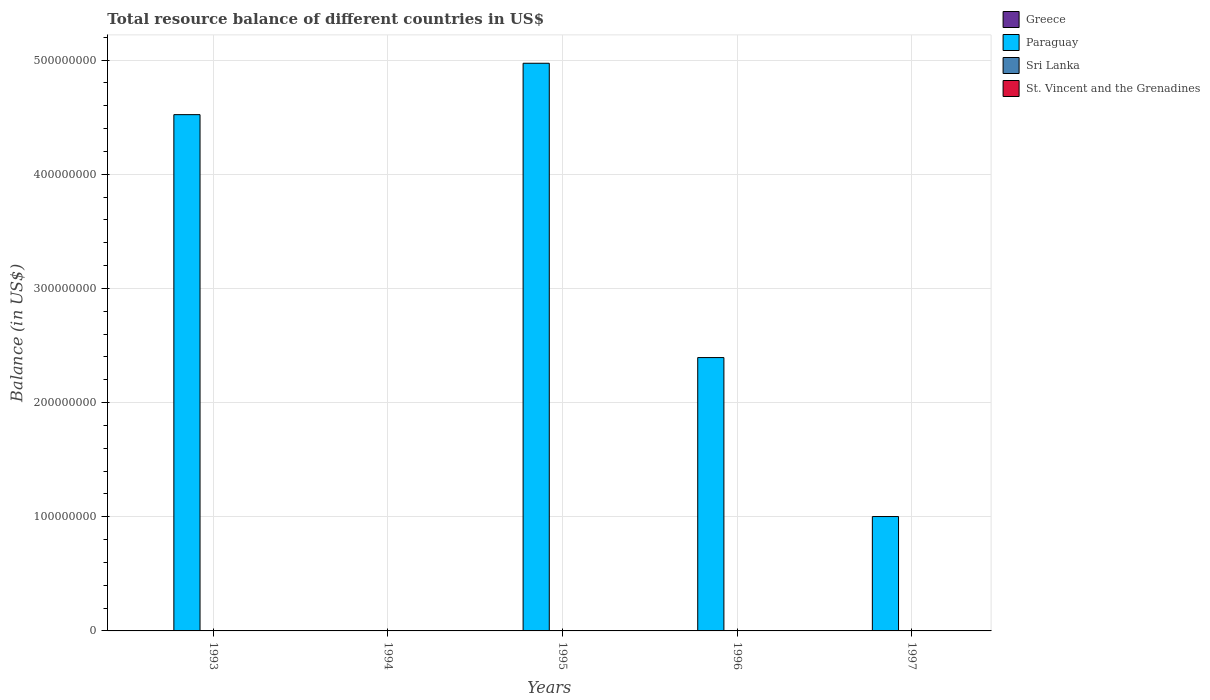Are the number of bars on each tick of the X-axis equal?
Your response must be concise. No. In how many cases, is the number of bars for a given year not equal to the number of legend labels?
Your answer should be very brief. 5. Across all years, what is the minimum total resource balance in Paraguay?
Your answer should be compact. 0. In which year was the total resource balance in Paraguay maximum?
Give a very brief answer. 1995. What is the total total resource balance in Paraguay in the graph?
Provide a short and direct response. 1.29e+09. What is the difference between the total resource balance in Paraguay in 1993 and that in 1997?
Give a very brief answer. 3.52e+08. What is the average total resource balance in Sri Lanka per year?
Your response must be concise. 0. In how many years, is the total resource balance in Greece greater than 180000000 US$?
Keep it short and to the point. 0. What is the ratio of the total resource balance in Paraguay in 1995 to that in 1996?
Your answer should be very brief. 2.08. What is the difference between the highest and the lowest total resource balance in Paraguay?
Ensure brevity in your answer.  4.97e+08. In how many years, is the total resource balance in St. Vincent and the Grenadines greater than the average total resource balance in St. Vincent and the Grenadines taken over all years?
Offer a terse response. 0. Is it the case that in every year, the sum of the total resource balance in St. Vincent and the Grenadines and total resource balance in Sri Lanka is greater than the sum of total resource balance in Paraguay and total resource balance in Greece?
Offer a very short reply. No. Is it the case that in every year, the sum of the total resource balance in Greece and total resource balance in St. Vincent and the Grenadines is greater than the total resource balance in Paraguay?
Make the answer very short. No. How many bars are there?
Provide a succinct answer. 4. How many years are there in the graph?
Keep it short and to the point. 5. Where does the legend appear in the graph?
Provide a short and direct response. Top right. What is the title of the graph?
Keep it short and to the point. Total resource balance of different countries in US$. What is the label or title of the Y-axis?
Your answer should be very brief. Balance (in US$). What is the Balance (in US$) of Greece in 1993?
Your response must be concise. 0. What is the Balance (in US$) in Paraguay in 1993?
Provide a short and direct response. 4.52e+08. What is the Balance (in US$) in Greece in 1994?
Offer a very short reply. 0. What is the Balance (in US$) of Paraguay in 1995?
Provide a succinct answer. 4.97e+08. What is the Balance (in US$) in Paraguay in 1996?
Make the answer very short. 2.39e+08. What is the Balance (in US$) of Sri Lanka in 1996?
Your answer should be compact. 0. What is the Balance (in US$) of Paraguay in 1997?
Ensure brevity in your answer.  1.00e+08. What is the Balance (in US$) of St. Vincent and the Grenadines in 1997?
Your response must be concise. 0. Across all years, what is the maximum Balance (in US$) of Paraguay?
Give a very brief answer. 4.97e+08. Across all years, what is the minimum Balance (in US$) in Paraguay?
Your answer should be very brief. 0. What is the total Balance (in US$) in Paraguay in the graph?
Make the answer very short. 1.29e+09. What is the total Balance (in US$) of Sri Lanka in the graph?
Keep it short and to the point. 0. What is the total Balance (in US$) in St. Vincent and the Grenadines in the graph?
Your response must be concise. 0. What is the difference between the Balance (in US$) of Paraguay in 1993 and that in 1995?
Offer a very short reply. -4.50e+07. What is the difference between the Balance (in US$) of Paraguay in 1993 and that in 1996?
Your answer should be compact. 2.13e+08. What is the difference between the Balance (in US$) in Paraguay in 1993 and that in 1997?
Ensure brevity in your answer.  3.52e+08. What is the difference between the Balance (in US$) of Paraguay in 1995 and that in 1996?
Give a very brief answer. 2.58e+08. What is the difference between the Balance (in US$) in Paraguay in 1995 and that in 1997?
Provide a succinct answer. 3.97e+08. What is the difference between the Balance (in US$) in Paraguay in 1996 and that in 1997?
Give a very brief answer. 1.39e+08. What is the average Balance (in US$) of Greece per year?
Offer a very short reply. 0. What is the average Balance (in US$) in Paraguay per year?
Ensure brevity in your answer.  2.58e+08. What is the average Balance (in US$) of Sri Lanka per year?
Make the answer very short. 0. What is the ratio of the Balance (in US$) in Paraguay in 1993 to that in 1995?
Keep it short and to the point. 0.91. What is the ratio of the Balance (in US$) of Paraguay in 1993 to that in 1996?
Your answer should be very brief. 1.89. What is the ratio of the Balance (in US$) in Paraguay in 1993 to that in 1997?
Offer a very short reply. 4.51. What is the ratio of the Balance (in US$) of Paraguay in 1995 to that in 1996?
Give a very brief answer. 2.08. What is the ratio of the Balance (in US$) of Paraguay in 1995 to that in 1997?
Offer a very short reply. 4.96. What is the ratio of the Balance (in US$) in Paraguay in 1996 to that in 1997?
Your answer should be compact. 2.39. What is the difference between the highest and the second highest Balance (in US$) of Paraguay?
Offer a terse response. 4.50e+07. What is the difference between the highest and the lowest Balance (in US$) in Paraguay?
Ensure brevity in your answer.  4.97e+08. 